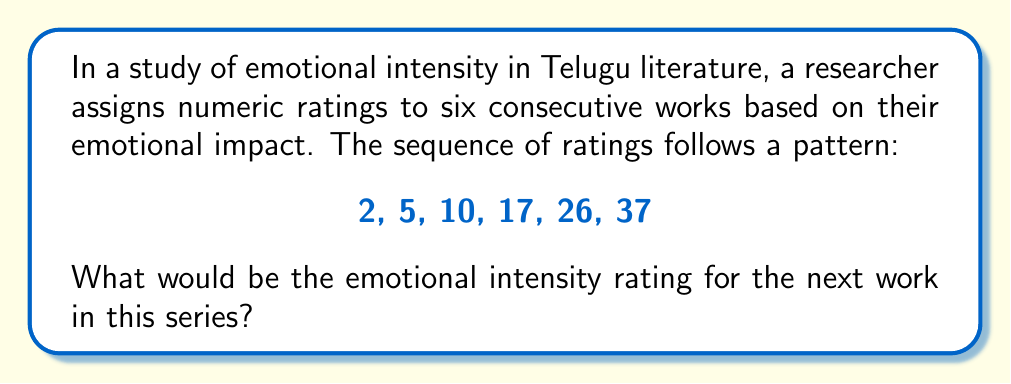Teach me how to tackle this problem. To solve this problem, we need to analyze the pattern in the given sequence:

2, 5, 10, 17, 26, 37

Let's examine the differences between consecutive terms:

1. From 2 to 5: $5 - 2 = 3$
2. From 5 to 10: $10 - 5 = 5$
3. From 10 to 17: $17 - 10 = 7$
4. From 17 to 26: $26 - 17 = 9$
5. From 26 to 37: $37 - 26 = 11$

We can observe that the differences are increasing by 2 each time:
$3, 5, 7, 9, 11$

This suggests that the next difference will be 13.

To find the next term in the original sequence, we add this difference to the last term:

$37 + 13 = 50$

Therefore, the emotional intensity rating for the next work in the series would be 50.

This pattern can be expressed mathematically as:

$$a_n = a_{n-1} + 2n + 1$$

Where $a_n$ is the nth term in the sequence, and $n$ starts at 1.
Answer: 50 